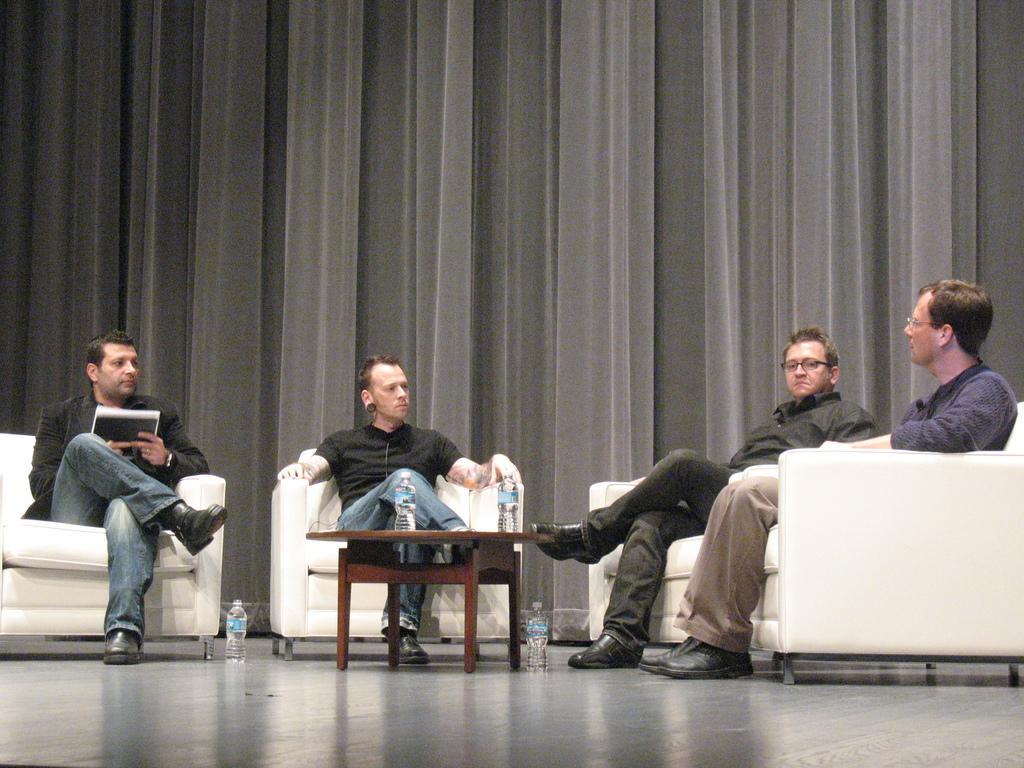How would you summarize this image in a sentence or two? As we can see in the image there are curtains and four people sitting on sofas. The man who is sitting on the left side is holding book. In the middle there is a table. On table there are bottles. 